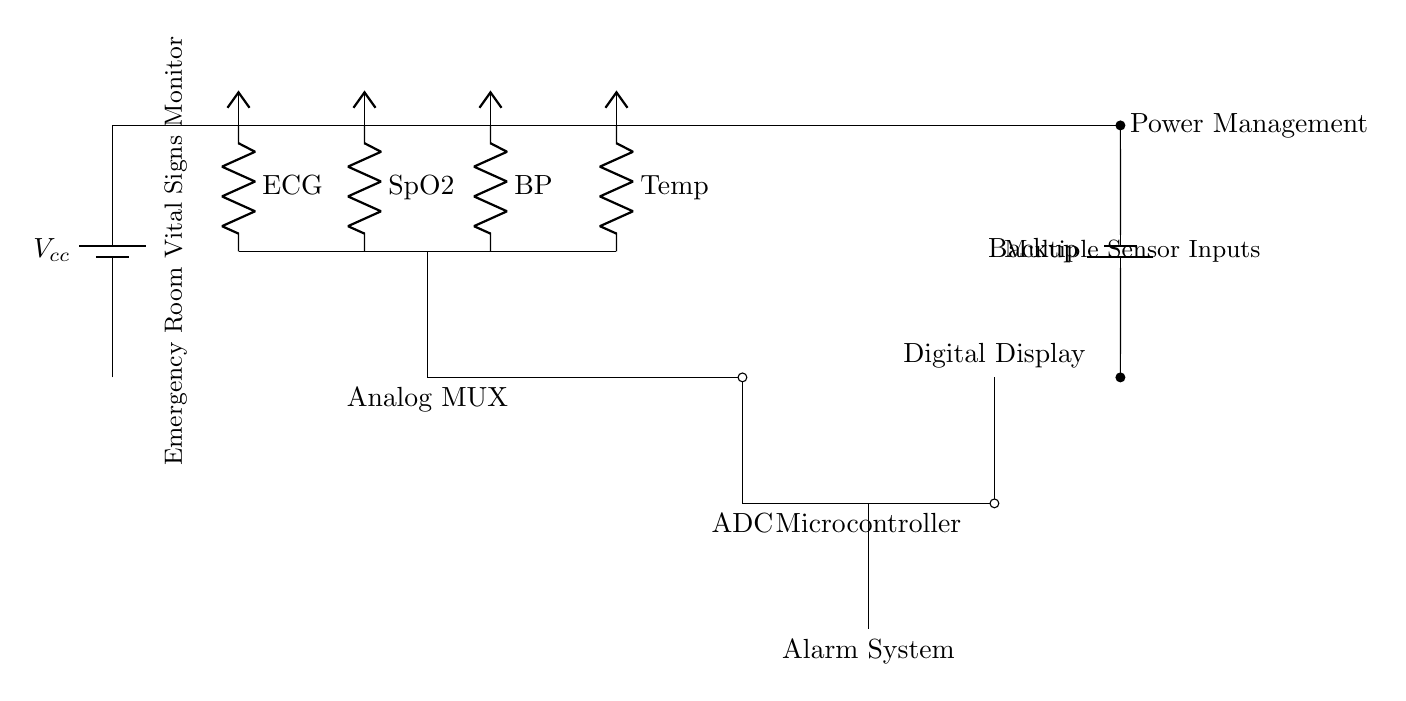What is the power supply for this circuit? The circuit uses a battery as the primary power supply, indicated by the battery symbol labeled $V_{cc}$. Additionally, there is a backup battery shown in the lower part of the circuit.
Answer: battery How many sensors are connected in this circuit? The circuit diagram has four sensors: ECG, SpO2, Blood Pressure (BP), and Temperature. Each sensor is shown connected to a resistor labeled with its name.
Answer: four What component converts analog signals to digital? The component labeled as ADC (Analog to Digital Converter) is responsible for converting the analog signals received from the sensors into digital signals for processing.
Answer: ADC Which component manages power in the circuit? The Power Management element controls the distribution of power to the other components and ensures proper operation; it is located at the top of the circuit diagram.
Answer: Power Management What is the function of the microcontroller in this circuit? The microcontroller processes the digital signals received from the ADC and controls the operation of the display and alarm system, which is shown in a distinct section of the circuit.
Answer: processing What does the alarm system do? The alarm system is intended to provide alerts based on the processed vital signs data from the microcontroller, thereby alerting caregivers in case of any emergency.
Answer: alerting What is the purpose of using an analog multiplexer? The analog multiplexer selects one of the four sensor signals to send to the ADC, allowing the ADC to process one signal at a time, thus managing multiple inputs effectively.
Answer: signal selection 